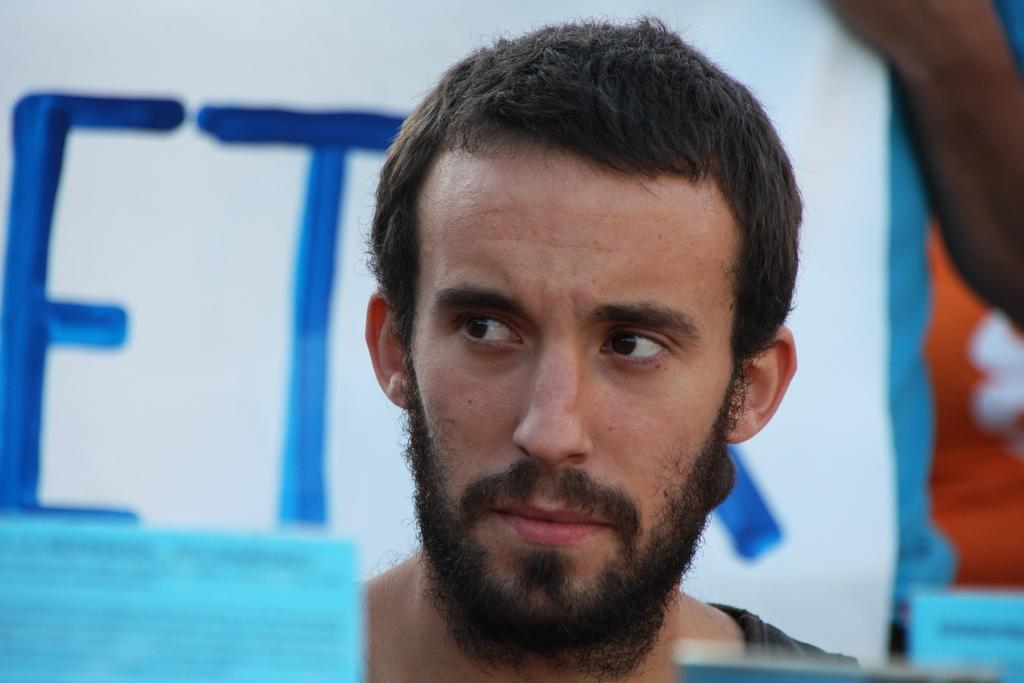What is the main subject of the image? There is a person in the image. What else can be seen in the image besides the person? There is a board with text in the image. What type of list can be seen on the person's arm in the image? There is no list or arm visible on the person in the image. 